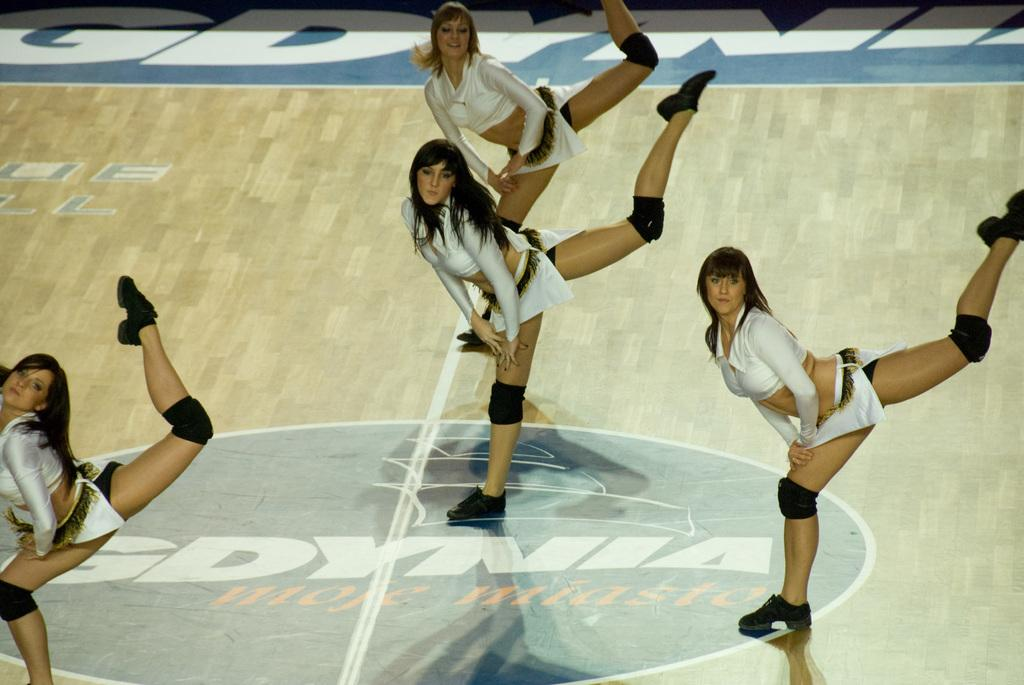Who is present in the image? There are girls in the image. What are the girls doing in the image? The girls are performing acrobatics. How many apples are being used in the acrobatics performance in the image? There are no apples present in the image; the girls are performing acrobatics without any apples. 